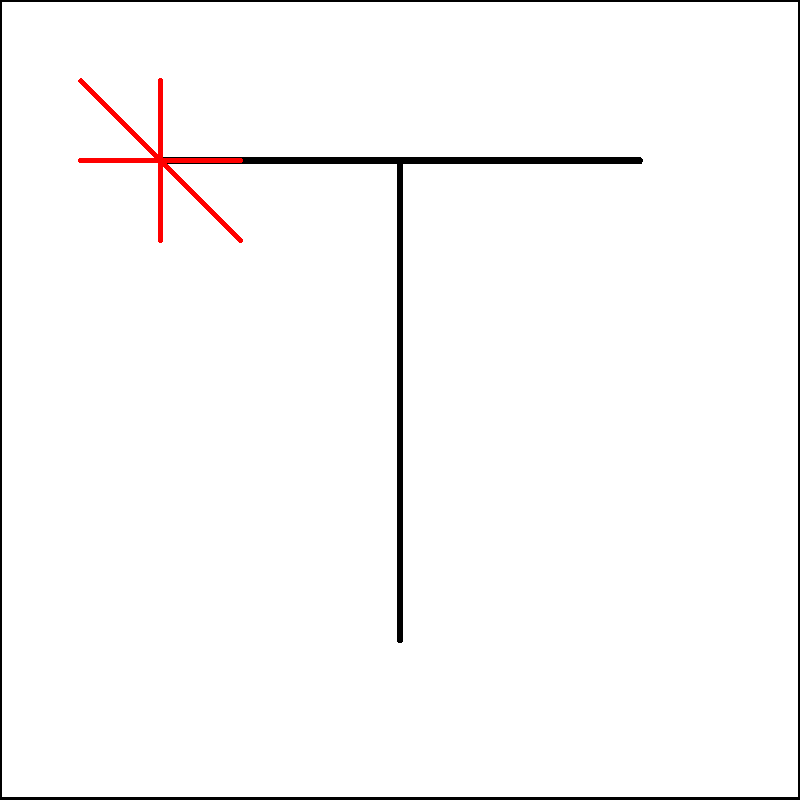Match the kanji character 上 (ue, meaning "up" or "above") to its pictographic origin. Which of the following best represents the original concept this character was derived from?

A) A person standing
B) A tree growing
C) An arrow pointing upward
D) A line above a horizon To answer this question, let's break down the process of understanding the kanji's pictographic origin:

1. Observe the kanji character 上 (ue) carefully. It consists of two main strokes: a horizontal line at the top and a vertical line extending downward from the middle of the horizontal line.

2. Consider the meaning of the kanji: "up" or "above."

3. Look at the provided pictograph in red, which represents the original form of the character:
   - It shows a short horizontal line with a vertical line above it.
   - This can be interpreted as something being above a reference point or horizon.

4. Compare this pictograph to the modern kanji form:
   - The horizontal line at the top of the kanji corresponds to the vertical line in the pictograph.
   - The vertical line in the kanji corresponds to the horizontal line in the pictograph.
   - The character has essentially been rotated 90 degrees clockwise from its original pictographic form.

5. Evaluate the given options:
   A) A person standing - This doesn't match the pictograph or the meaning.
   B) A tree growing - While this could represent "up," it doesn't match the simple pictograph.
   C) An arrow pointing upward - This is closer but still more complex than the actual pictograph.
   D) A line above a horizon - This most closely matches the original pictograph and the concept of "above."

Therefore, the correct answer is D, as it best represents the original concept from which the kanji 上 was derived.
Answer: D) A line above a horizon 